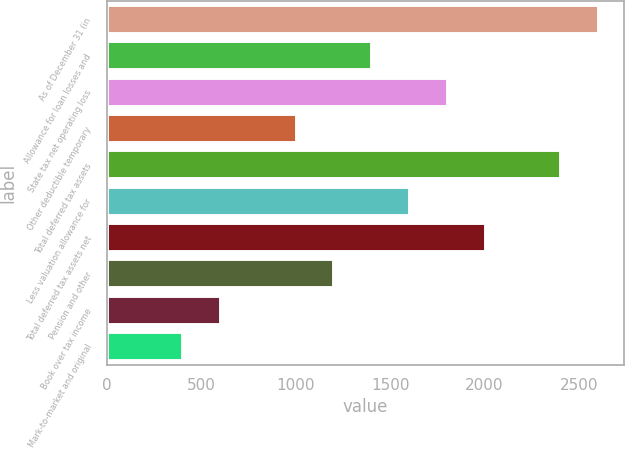Convert chart. <chart><loc_0><loc_0><loc_500><loc_500><bar_chart><fcel>As of December 31 (in<fcel>Allowance for loan losses and<fcel>State tax net operating loss<fcel>Other deductible temporary<fcel>Total deferred tax assets<fcel>Less valuation allowance for<fcel>Total deferred tax assets net<fcel>Pension and other<fcel>Book over tax income<fcel>Mark-to-market and original<nl><fcel>2606.72<fcel>1405.28<fcel>1805.76<fcel>1004.8<fcel>2406.48<fcel>1605.52<fcel>2006<fcel>1205.04<fcel>604.32<fcel>404.08<nl></chart> 